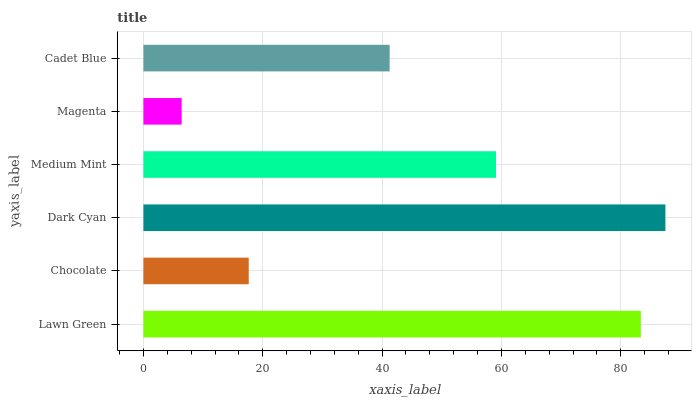Is Magenta the minimum?
Answer yes or no. Yes. Is Dark Cyan the maximum?
Answer yes or no. Yes. Is Chocolate the minimum?
Answer yes or no. No. Is Chocolate the maximum?
Answer yes or no. No. Is Lawn Green greater than Chocolate?
Answer yes or no. Yes. Is Chocolate less than Lawn Green?
Answer yes or no. Yes. Is Chocolate greater than Lawn Green?
Answer yes or no. No. Is Lawn Green less than Chocolate?
Answer yes or no. No. Is Medium Mint the high median?
Answer yes or no. Yes. Is Cadet Blue the low median?
Answer yes or no. Yes. Is Chocolate the high median?
Answer yes or no. No. Is Lawn Green the low median?
Answer yes or no. No. 